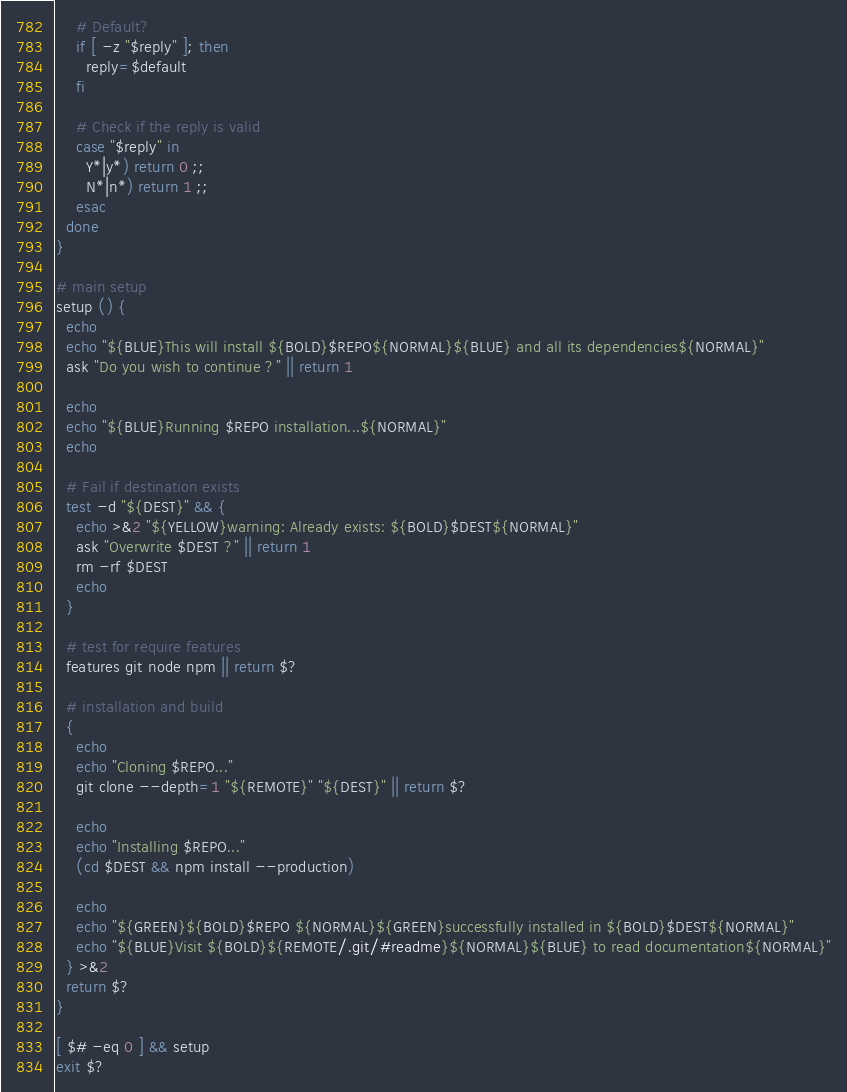<code> <loc_0><loc_0><loc_500><loc_500><_Bash_>
    # Default?
    if [ -z "$reply" ]; then
      reply=$default
    fi

    # Check if the reply is valid
    case "$reply" in
      Y*|y*) return 0 ;;
      N*|n*) return 1 ;;
    esac
  done
}

# main setup
setup () {
  echo
  echo "${BLUE}This will install ${BOLD}$REPO${NORMAL}${BLUE} and all its dependencies${NORMAL}"
  ask "Do you wish to continue ?" || return 1

  echo
  echo "${BLUE}Running $REPO installation...${NORMAL}"
  echo

  # Fail if destination exists
  test -d "${DEST}" && {
    echo >&2 "${YELLOW}warning: Already exists: ${BOLD}$DEST${NORMAL}"
    ask "Overwrite $DEST ?" || return 1
    rm -rf $DEST
    echo
  }

  # test for require features
  features git node npm || return $?

  # installation and build
  {
    echo
    echo "Cloning $REPO..."
    git clone --depth=1 "${REMOTE}" "${DEST}" || return $?

    echo
    echo "Installing $REPO..."
    (cd $DEST && npm install --production)

    echo
    echo "${GREEN}${BOLD}$REPO ${NORMAL}${GREEN}successfully installed in ${BOLD}$DEST${NORMAL}"
    echo "${BLUE}Visit ${BOLD}${REMOTE/.git/#readme}${NORMAL}${BLUE} to read documentation${NORMAL}"
  } >&2
  return $?
}

[ $# -eq 0 ] && setup
exit $?
</code> 